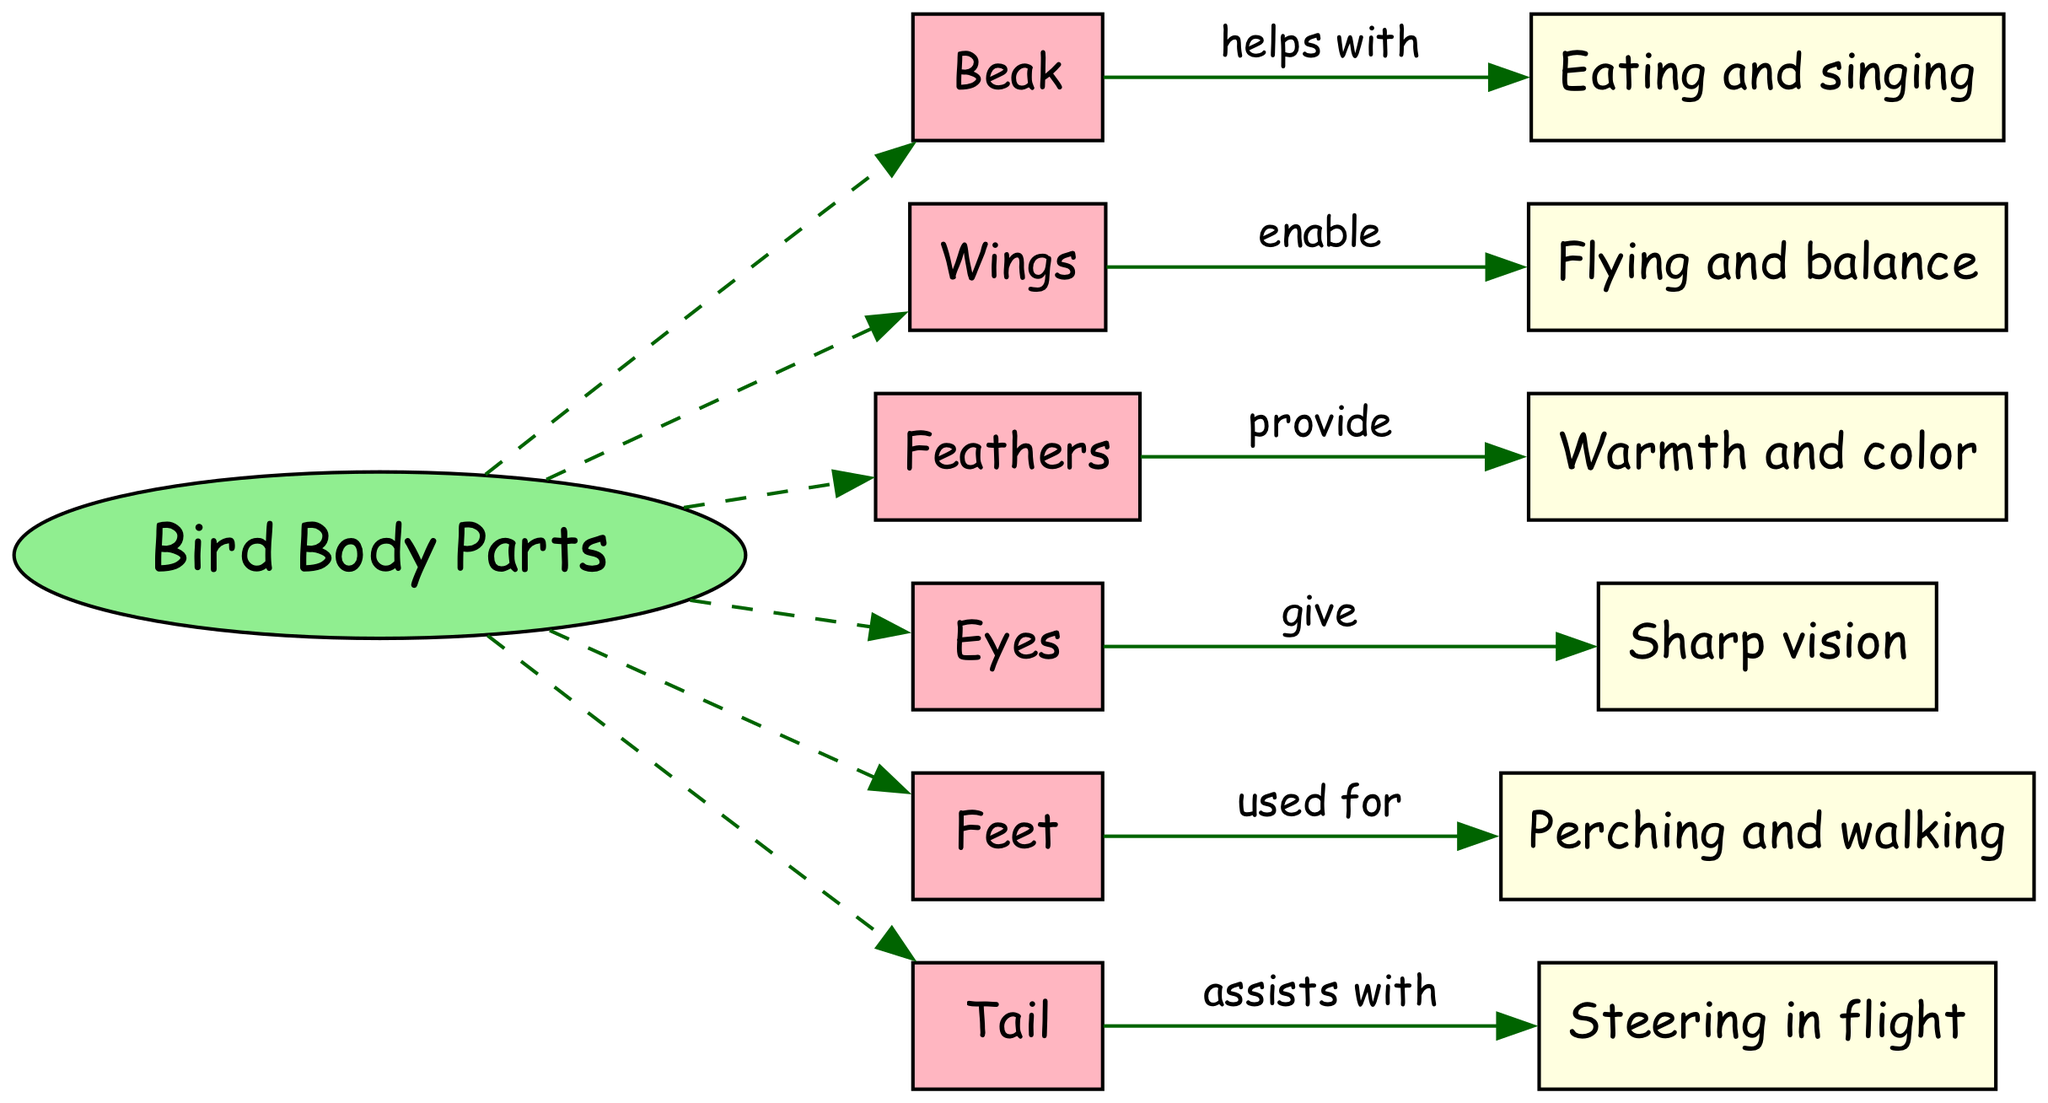What is the main topic of the diagram? The main topic can be found in the center of the diagram, denoted by an ellipse. It clearly states "Bird Body Parts".
Answer: Bird Body Parts How many parts of a bird's body are listed in the diagram? To find the number of parts, I can count the elements listed in the "Elements" section of the diagram. There are six parts: Beak, Wings, Feathers, Eyes, Feet, and Tail.
Answer: 6 What function is associated with the beak? The function associated with the beak can be found by following the connection from the beak node. It indicates that the beak is used for "Eating and singing".
Answer: Eating and singing How does the tail assist birds? By checking the connection from the tail node, it shows that the tail "assists with" "Steering in flight", explaining its role in maneuverability.
Answer: Steering in flight Which body part provides warmth and color? The function linked to feathers indicates that they "provide" warmth and color. I can find this by following the connection from the Feathers node.
Answer: Feathers What part of a bird's body allows it to fly? By looking at the Wings node and its associated function, it is clear that wings "enable" flying. Therefore, wings are the part that allows flight.
Answer: Wings Which part is associated with sharp vision? Looking at the Eyes node, I can see that it gives "Sharp vision", establishing its importance for sight.
Answer: Eyes What are the functions of feet in a bird's body? Feet are indicated in the diagram to be "used for" "Perching and walking", which shows what they help the bird do.
Answer: Perching and walking How many connections are shown in the diagram? To find the number of connections, I can count each line that links the bird body parts to their respective functions. There are six connections.
Answer: 6 